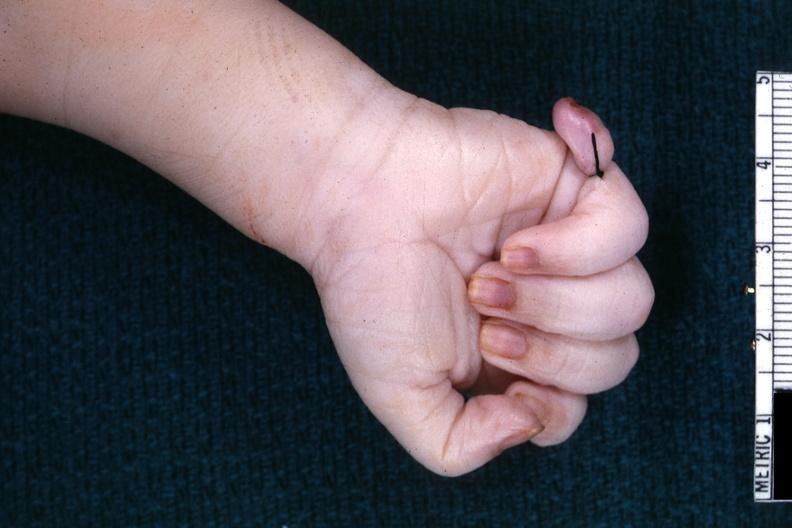how does this image show good shot of sixth finger?
Answer the question using a single word or phrase. With ligature on it 